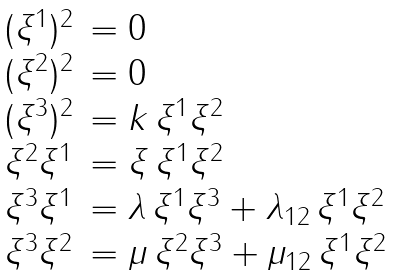Convert formula to latex. <formula><loc_0><loc_0><loc_500><loc_500>\begin{array} { l l l } & ( \xi ^ { 1 } ) ^ { 2 } & = 0 \\ & ( \xi ^ { 2 } ) ^ { 2 } & = 0 \\ & ( \xi ^ { 3 } ) ^ { 2 } & = k \, \xi ^ { 1 } \xi ^ { 2 } \\ & \xi ^ { 2 } \xi ^ { 1 } & = \xi \, \xi ^ { 1 } \xi ^ { 2 } \\ & \xi ^ { 3 } \xi ^ { 1 } & = \lambda \, \xi ^ { 1 } \xi ^ { 3 } + \lambda _ { 1 2 } \, \xi ^ { 1 } \xi ^ { 2 } \\ & \xi ^ { 3 } \xi ^ { 2 } & = \mu \, \xi ^ { 2 } \xi ^ { 3 } + \mu _ { 1 2 } \, \xi ^ { 1 } \xi ^ { 2 } \\ \end{array}</formula> 